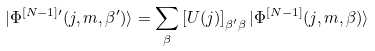Convert formula to latex. <formula><loc_0><loc_0><loc_500><loc_500>| \Phi ^ { [ N - 1 ] \prime } ( j , m , \beta ^ { \prime } ) \rangle = \sum _ { \beta } \left [ U ( j ) \right ] _ { \beta ^ { \prime } \beta } | \Phi ^ { [ N - 1 ] } ( j , m , \beta ) \rangle</formula> 